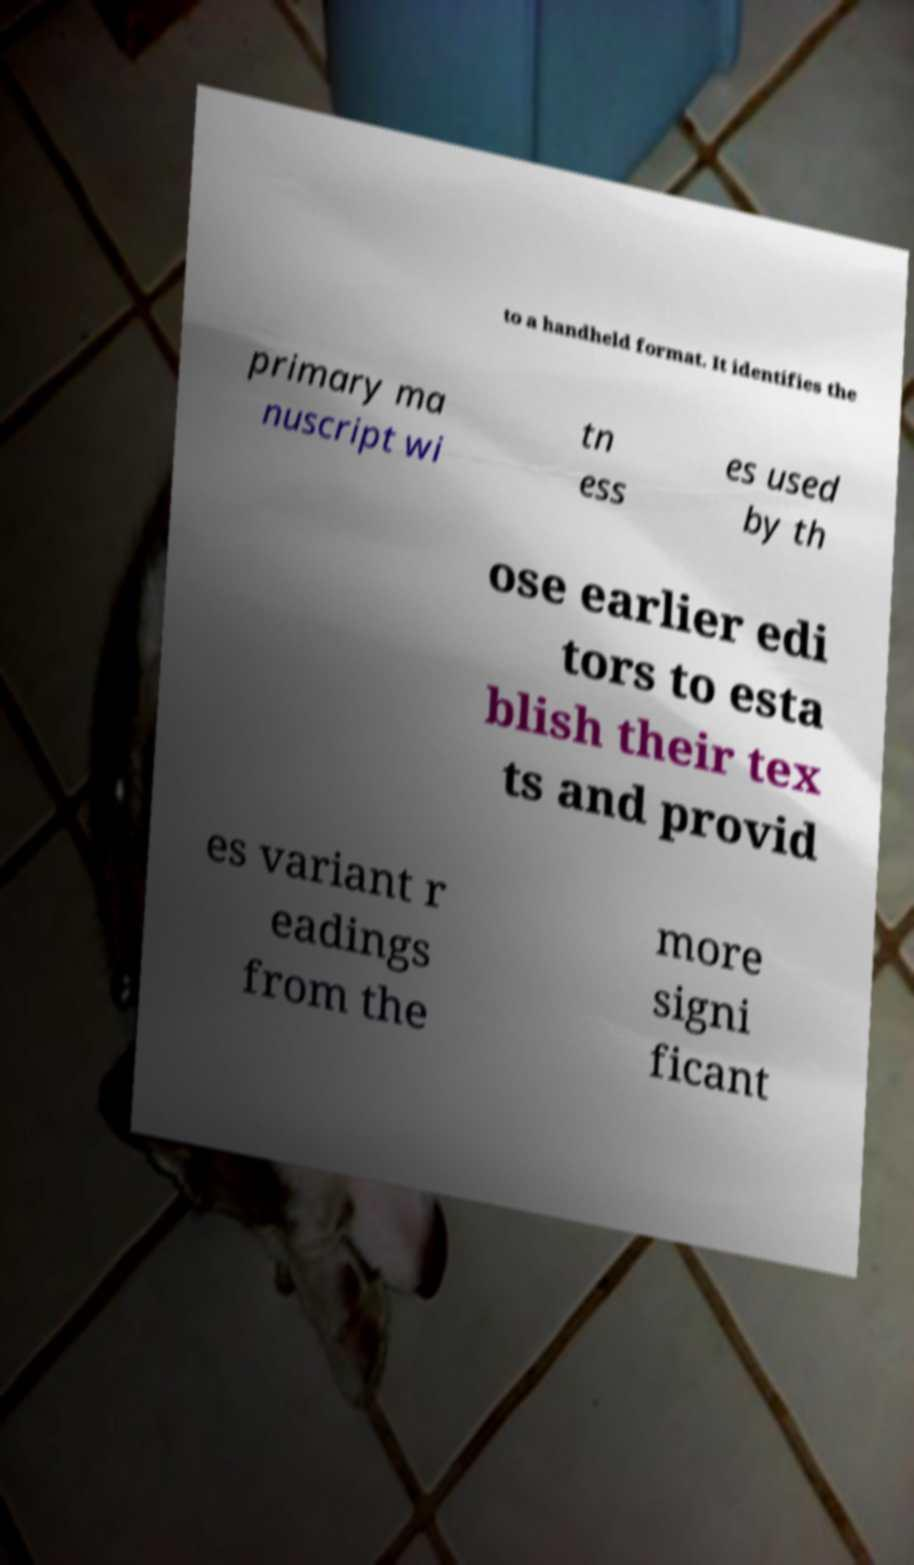Could you assist in decoding the text presented in this image and type it out clearly? to a handheld format. It identifies the primary ma nuscript wi tn ess es used by th ose earlier edi tors to esta blish their tex ts and provid es variant r eadings from the more signi ficant 